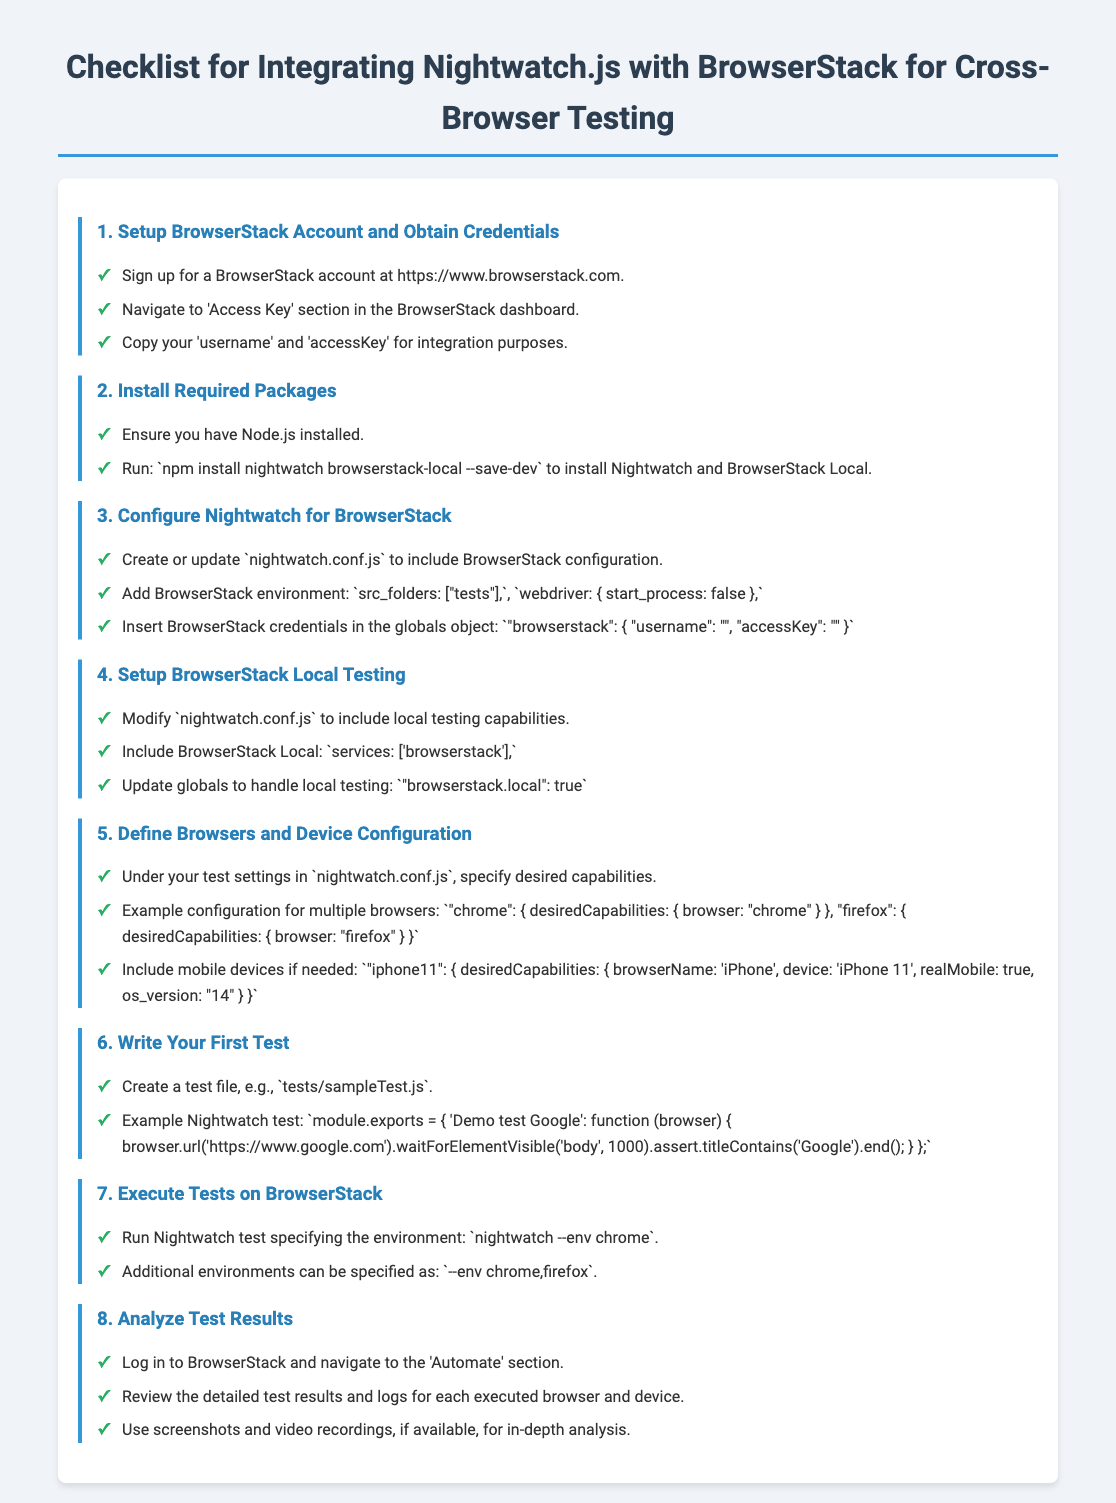what is the first step in the checklist? The first step is to set up a BrowserStack account and obtain credentials.
Answer: Setup BrowserStack Account and Obtain Credentials what command is used to install Nightwatch and BrowserStack Local? The command used to install Nightwatch and BrowserStack Local is included in the second checklist item.
Answer: npm install nightwatch browserstack-local --save-dev what file needs to be created or updated for BrowserStack configuration? The file that needs to be created or updated is specified in the third checklist item.
Answer: nightwatch.conf.js how do you specify that local testing is enabled? The method of specifying local testing is found in the fourth checklist item.
Answer: "browserstack.local": true what is an example browser included in the configuration? The document provides an example browser in the fifth checklist item.
Answer: chrome what command is used to run a Nightwatch test? The command to run a Nightwatch test is found in the seventh checklist item.
Answer: nightwatch --env chrome where can you find detailed test results and logs? The location for detailed test results and logs is mentioned in the eighth checklist item.
Answer: 'Automate' section in BrowserStack what is the purpose of the checklist document? The purpose of the checklist document is expressed in the title of the document.
Answer: Integrating Nightwatch.js with BrowserStack for Cross-Browser Testing 